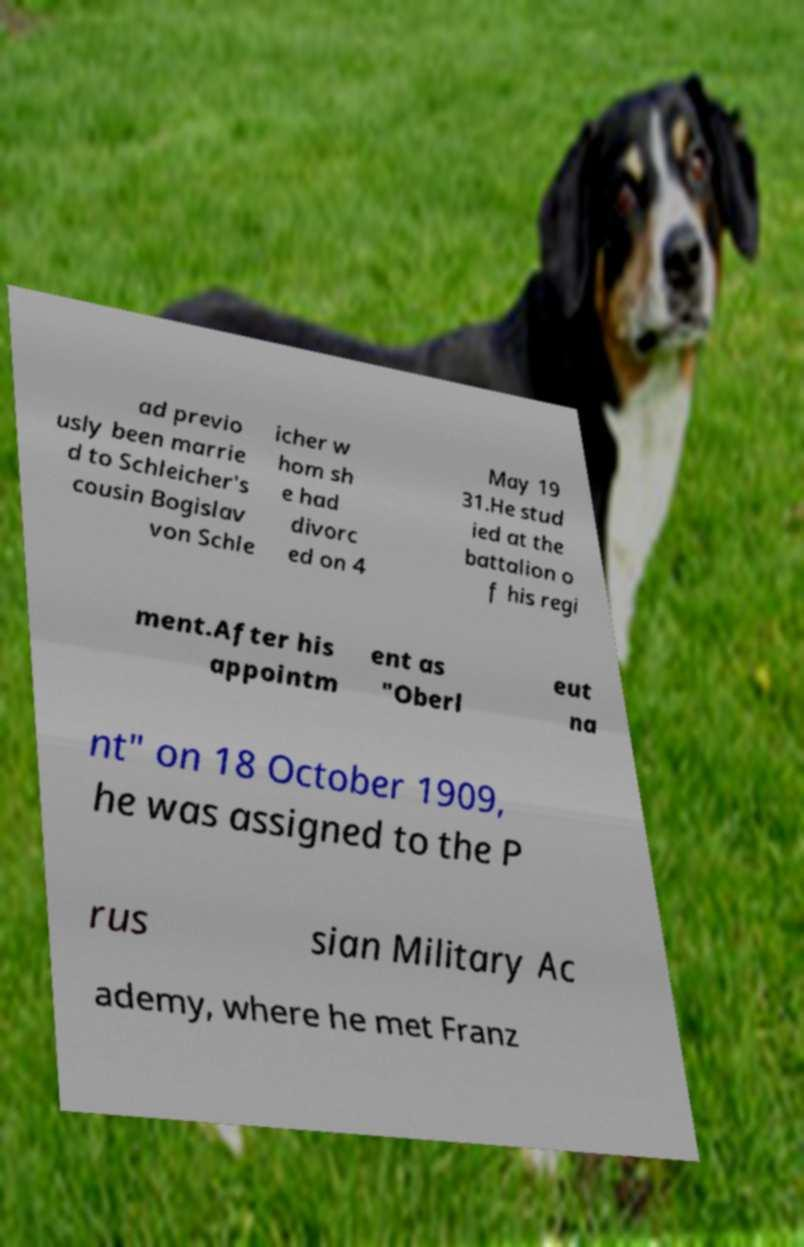Can you accurately transcribe the text from the provided image for me? ad previo usly been marrie d to Schleicher's cousin Bogislav von Schle icher w hom sh e had divorc ed on 4 May 19 31.He stud ied at the battalion o f his regi ment.After his appointm ent as "Oberl eut na nt" on 18 October 1909, he was assigned to the P rus sian Military Ac ademy, where he met Franz 